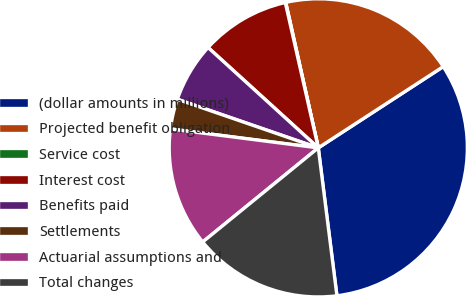<chart> <loc_0><loc_0><loc_500><loc_500><pie_chart><fcel>(dollar amounts in millions)<fcel>Projected benefit obligation<fcel>Service cost<fcel>Interest cost<fcel>Benefits paid<fcel>Settlements<fcel>Actuarial assumptions and<fcel>Total changes<nl><fcel>32.18%<fcel>19.33%<fcel>0.05%<fcel>9.69%<fcel>6.47%<fcel>3.26%<fcel>12.9%<fcel>16.12%<nl></chart> 